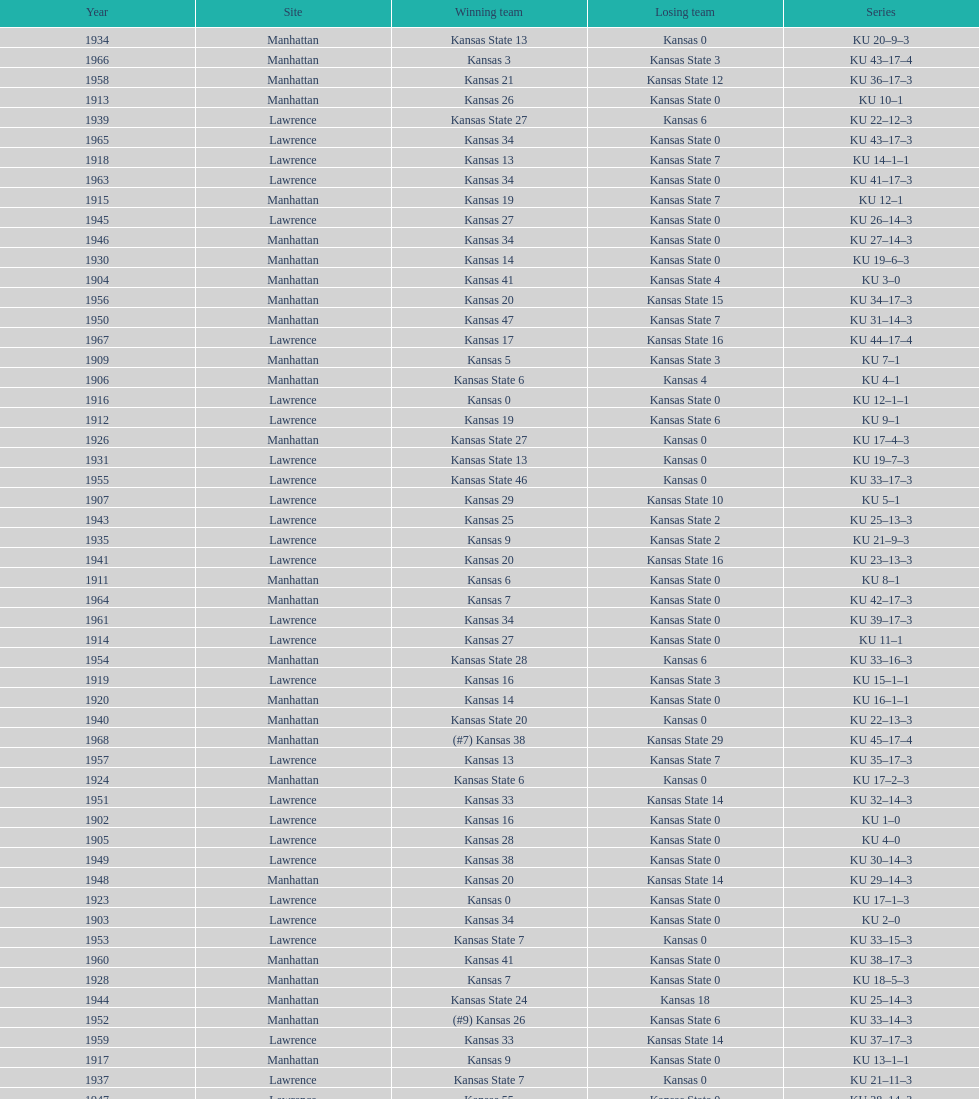How many times did kansas and kansas state play in lawrence from 1902-1968? 34. 